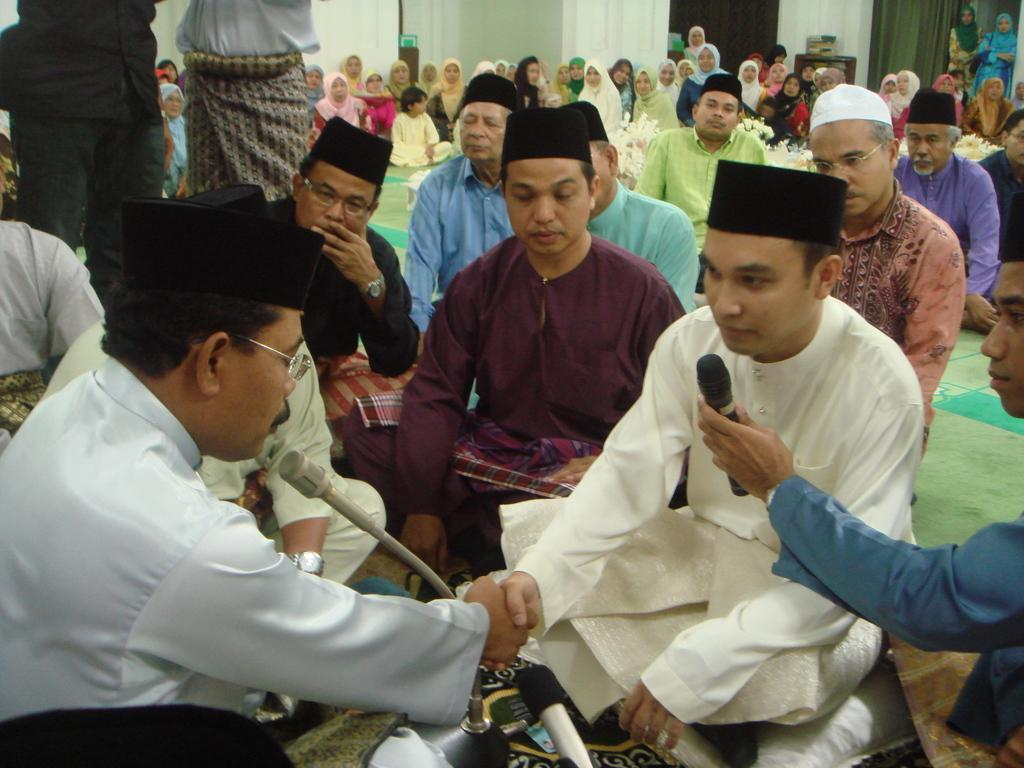What are the people in the image doing? The people in the image are sitting on a mat. What object is present at the front of the image? There is a microphone (mike) at the front of the image. What can be seen at the back side of the image? There are curtains at the back side of the image. What piece of furniture is visible in the image? There is a table in the image. What is placed on top of the table? There is an object on top of the table. Can you tell me how many pens are on the table in the image? There is no mention of pens in the image; only a microphone, curtains, and an unspecified object on the table are mentioned. How does the person sitting on the mat sneeze in the image? There is no indication of anyone sneezing in the image. 